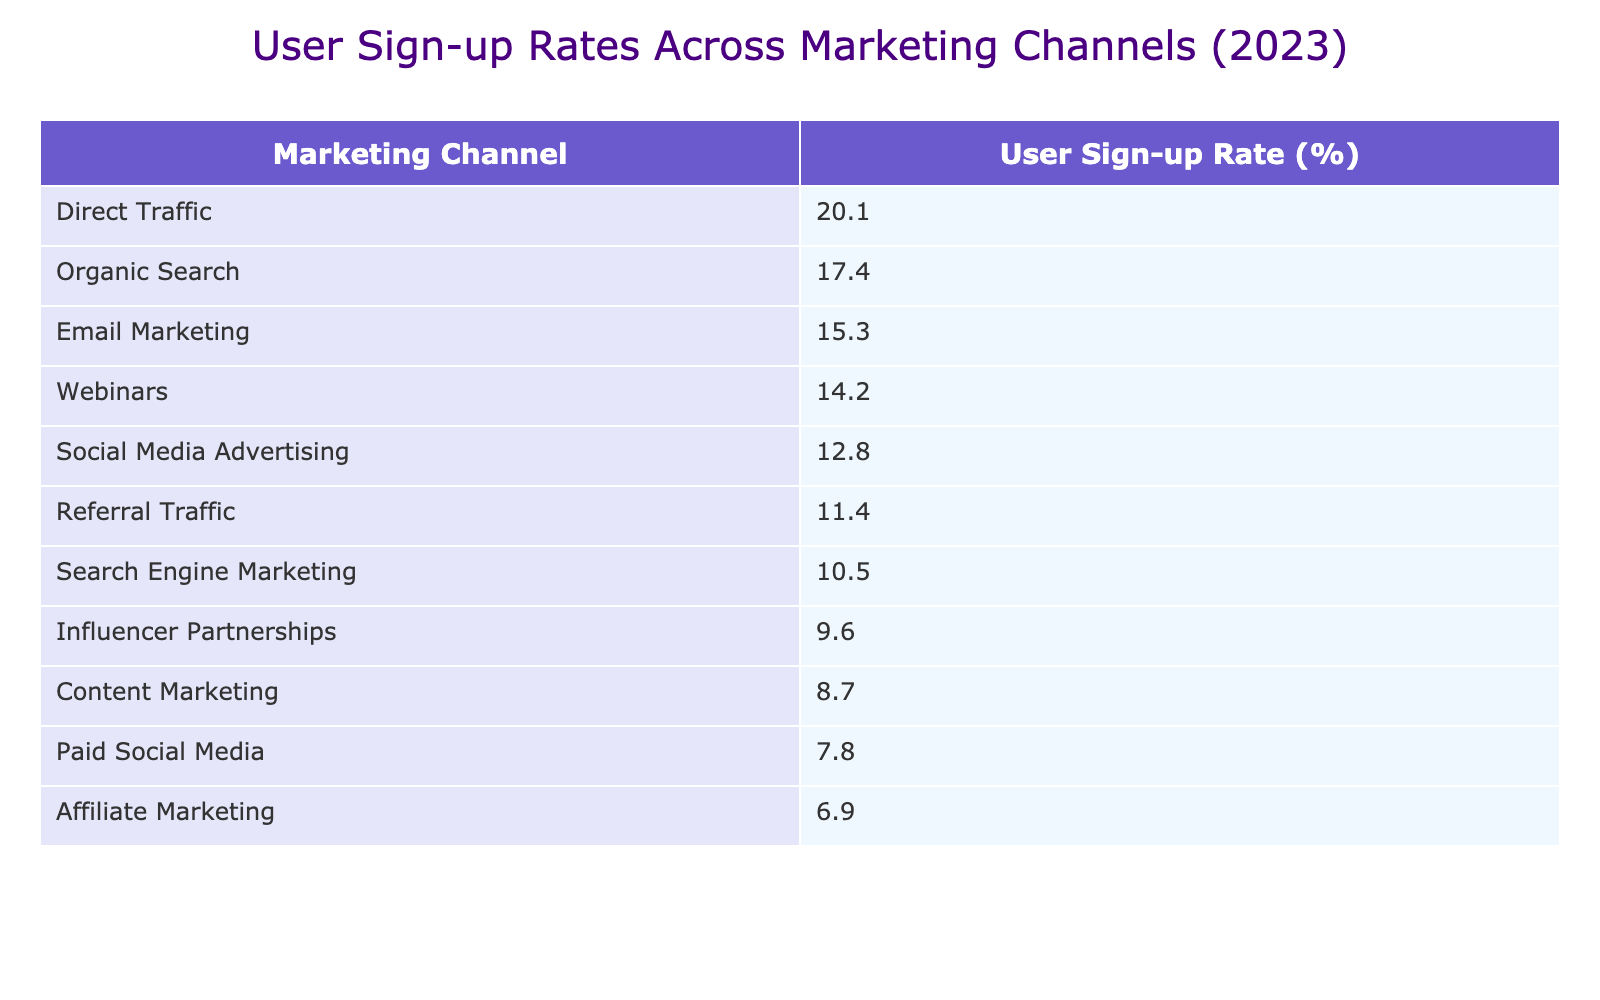What is the User Sign-up Rate for Direct Traffic? The table shows that the User Sign-up Rate for Direct Traffic is 20.1%. This value is directly listed under the relevant marketing channel in the table.
Answer: 20.1% Which marketing channel has the highest sign-up rate? According to the table, Direct Traffic has the highest User Sign-up Rate, which is 20.1%. This can be confirmed by scanning the User Sign-up Rate column for the maximum value.
Answer: Direct Traffic What is the average User Sign-up Rate for all marketing channels listed? First, we need to add up all the User Sign-up Rates: 15.3 + 12.8 + 10.5 + 8.7 + 6.9 + 20.1 + 11.4 + 14.2 + 9.6 + 17.4 + 7.8 =  130.7. There are 11 marketing channels, so we divide the total by 11: 130.7 / 11 = 11.JP.
Answer: 11.9 Is the User Sign-up Rate for Content Marketing greater than 10%? The User Sign-up Rate for Content Marketing is 8.7%, which is less than 10%. By checking the relevant value in the table, we can easily confirm this.
Answer: No Which two marketing channels have the closest User Sign-up Rates? Comparing the User Sign-up Rates from the table, Affiliate Marketing (6.9%) and Paid Social Media (7.8%) have the closest values. To determine this, we look for the smallest differences between the rates from the table.
Answer: Affiliate Marketing and Paid Social Media What is the difference between the User Sign-up Rates for Organic Search and Social Media Advertising? The User Sign-up Rate for Organic Search is 17.4% and for Social Media Advertising is 12.8%. By subtracting the latter from the former, we find the difference is 17.4 - 12.8 = 4.6%.
Answer: 4.6% Do any of the marketing channels have a User Sign-up Rate of more than 15%? Yes, there are several marketing channels with a User Sign-up Rate above 15%, specifically Direct Traffic (20.1%), Organic Search (17.4%), and Email Marketing (15.3%). This can be confirmed by checking the User Sign-up Rates listed in the table.
Answer: Yes What percentage of marketing channels have a User Sign-up Rate below 10%? In the table, there are two marketing channels (Affiliate Marketing at 6.9% and Paid Social Media at 7.8%) that have User Sign-up Rates below 10%. There is a total of 11 channels, so the percentage is (2/11)*100 ≈ 18.18%.
Answer: Approximately 18.18% 